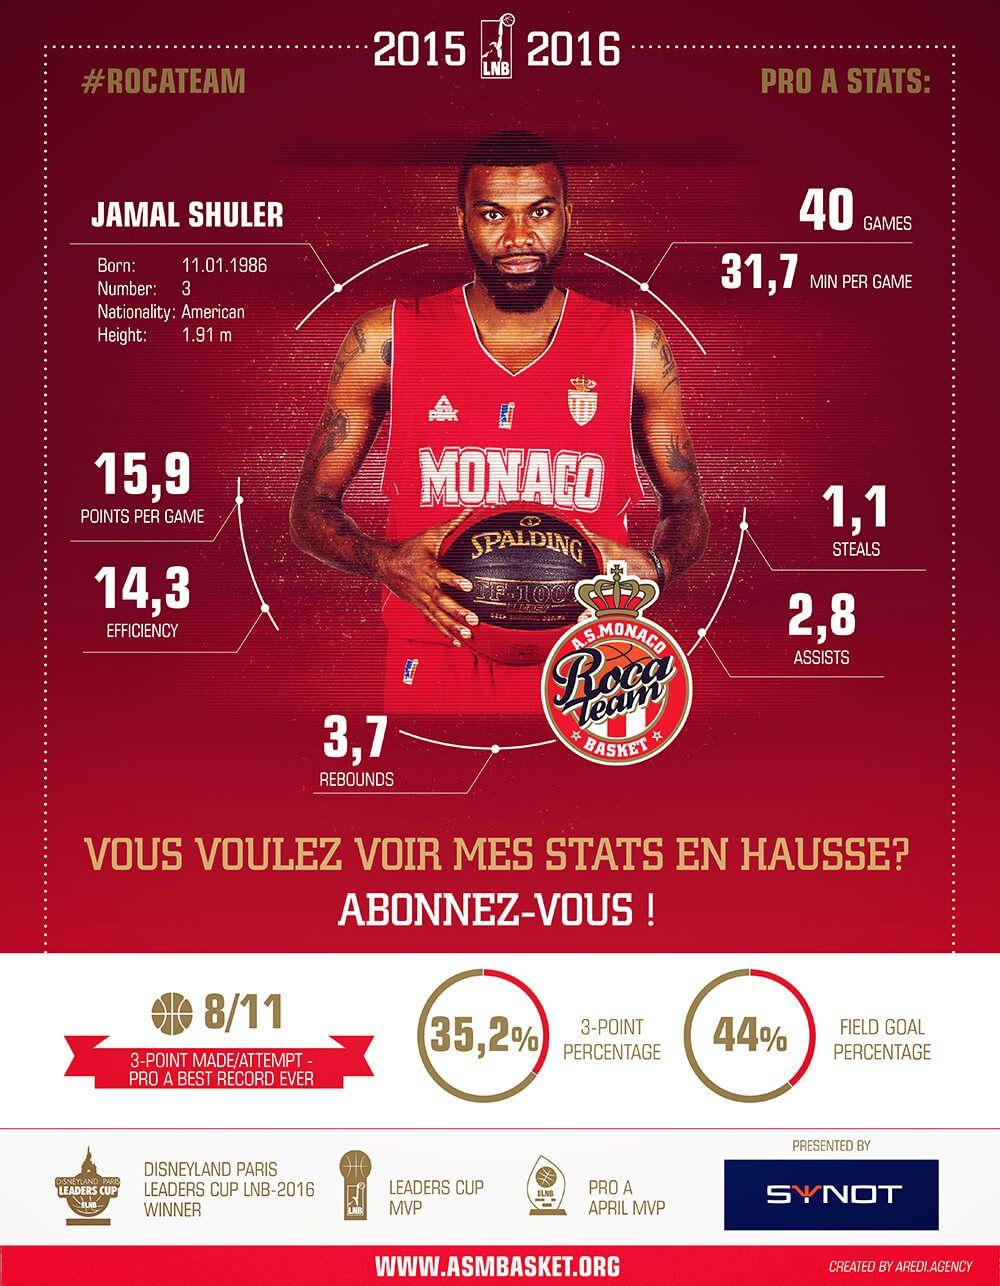Point out several critical features in this image. I declare that the player Jamal Shuler is wearing the jersey of AS Monaco Basket club. According to the data, Shuler's average points per game are 31.7, 15.9, and 1.1 respectively, with the highest being 15.9. According to the given data, the number of assists scored by Shuler in the previous season is 2.8. Jamal Shuler is a member of the Roca Team basketball team. 